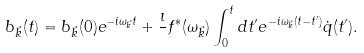Convert formula to latex. <formula><loc_0><loc_0><loc_500><loc_500>b _ { \vec { k } } ( t ) = b _ { \vec { k } } ( 0 ) e ^ { - i \omega _ { \vec { k } } t } + \frac { \imath } { } f ^ { * } ( \omega _ { \vec { k } } ) \int _ { 0 } ^ { t } d t ^ { \prime } e ^ { - i \omega _ { \vec { k } } ( t - t ^ { \prime } ) } \dot { q } ( t ^ { \prime } ) .</formula> 